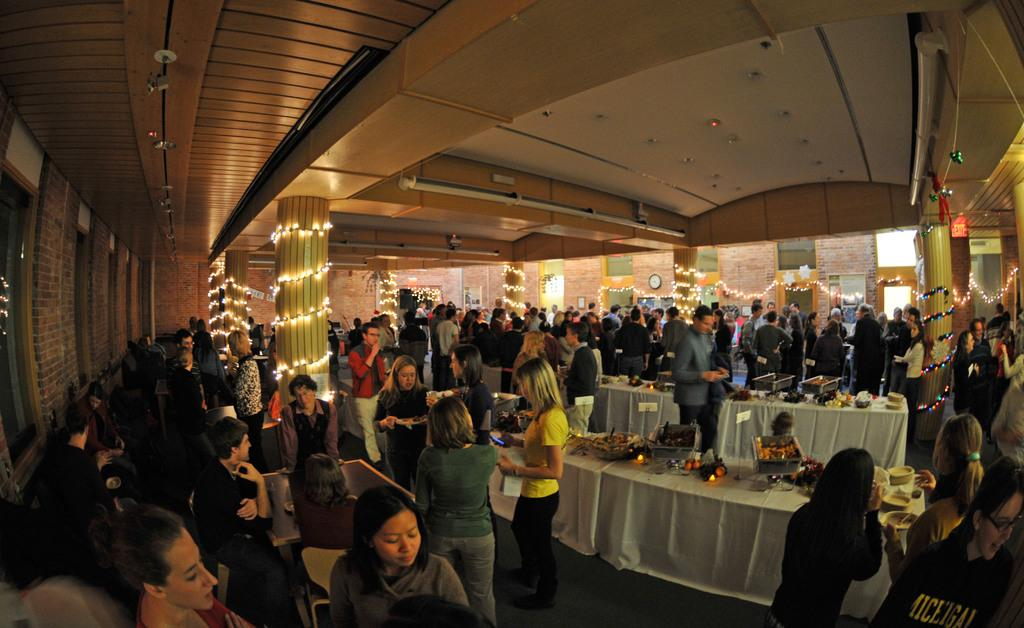How are the people in the image positioned? Some people are standing, while others are sitting on chairs. What can be found on the tables in the image? There are items on the tables. What type of signage is present in the image? Name boards are present in the image. What kind of lighting is visible in the image? Rope lights and lights are present in the image. What architectural features can be seen in the image? Pillars are present in the image. What can be seen through the windows in the image? Windows are visible in the image. What phase is the moon in during the battle depicted in the image? There is no moon or battle depicted in the image; it features a group of people in a setting with tables, chairs, and various lighting and signage. 